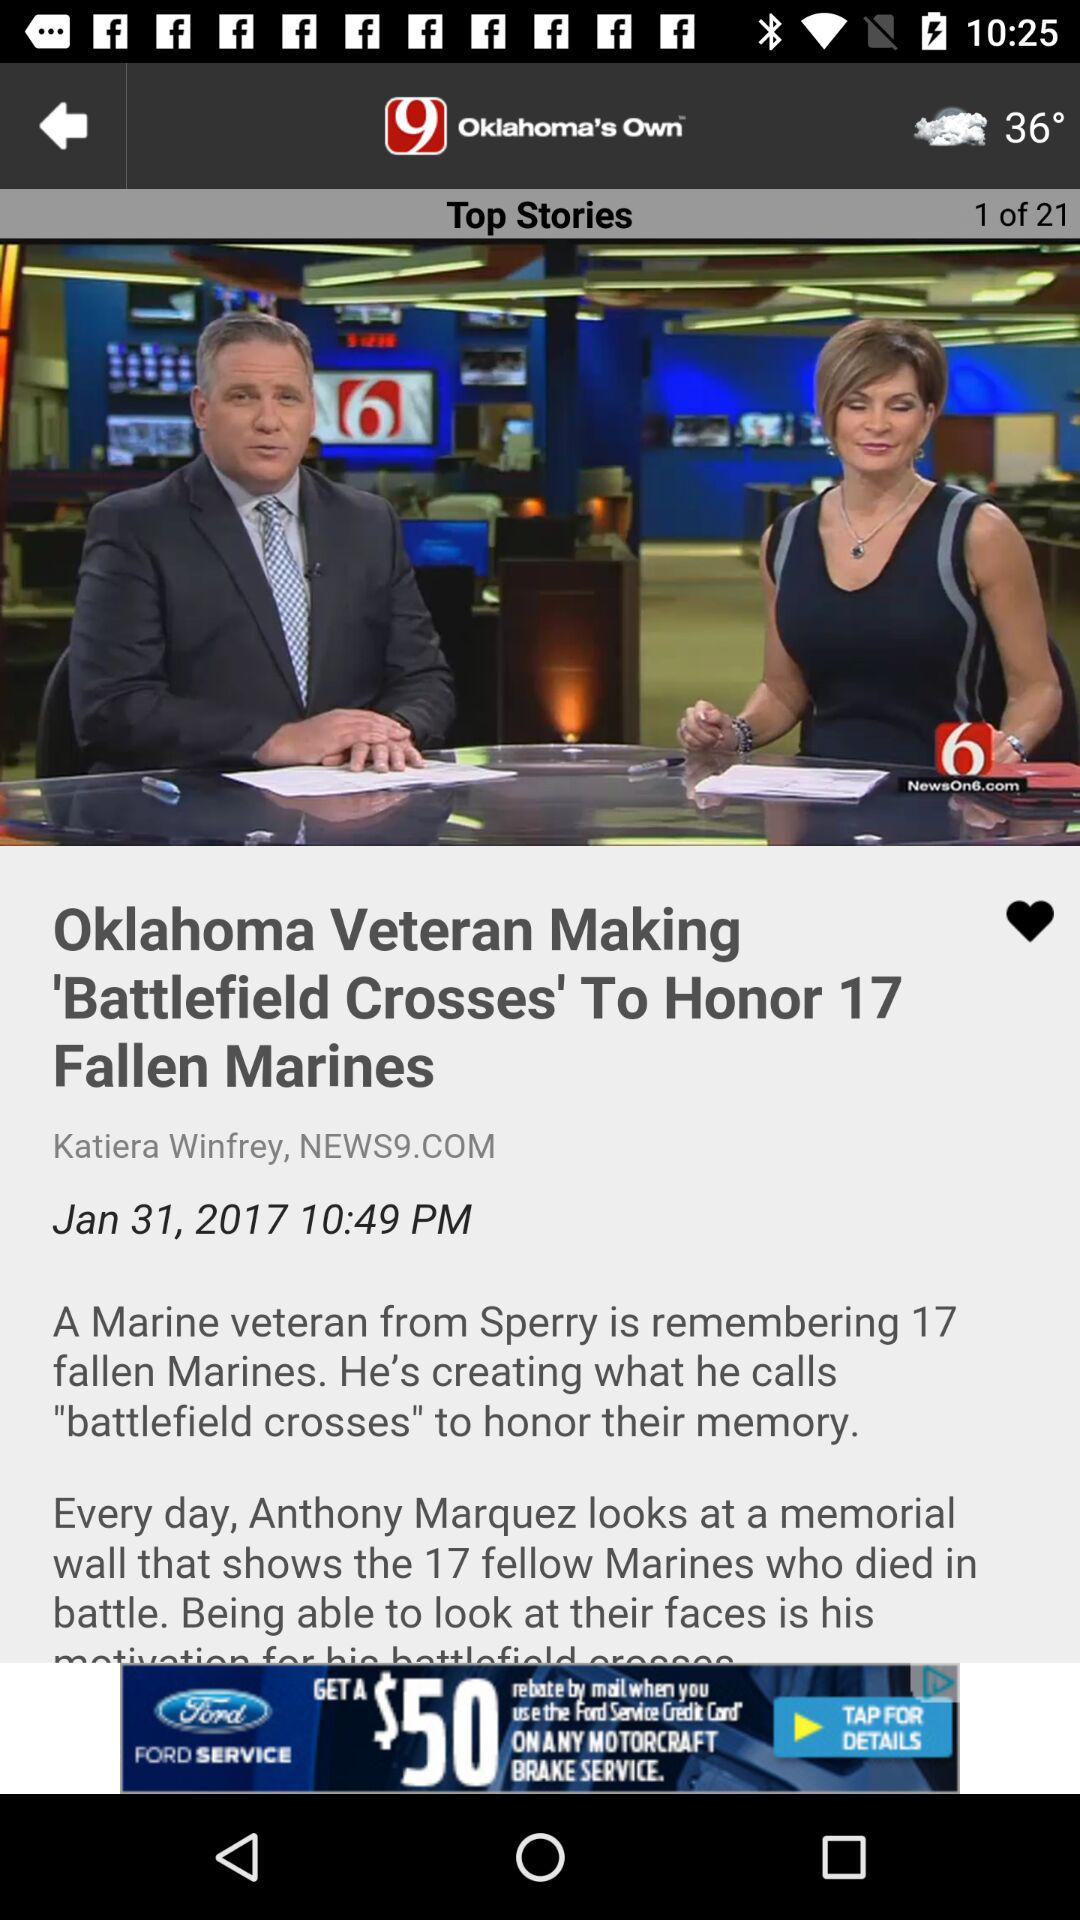What is the author name? The author name is Katiera Winfrey. 